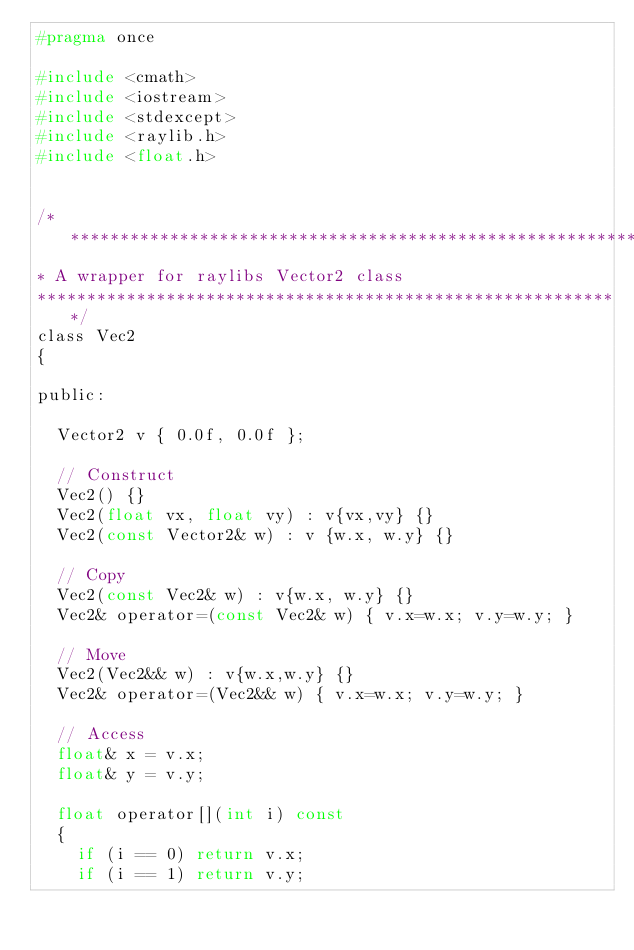<code> <loc_0><loc_0><loc_500><loc_500><_C_>#pragma once

#include <cmath>
#include <iostream>
#include <stdexcept>
#include <raylib.h>
#include <float.h>


/***********************************************************
* A wrapper for raylibs Vector2 class
***********************************************************/
class Vec2
{

public:

  Vector2 v { 0.0f, 0.0f };

  // Construct
  Vec2() {}
  Vec2(float vx, float vy) : v{vx,vy} {}
  Vec2(const Vector2& w) : v {w.x, w.y} {}

  // Copy 
  Vec2(const Vec2& w) : v{w.x, w.y} {}
  Vec2& operator=(const Vec2& w) { v.x=w.x; v.y=w.y; }

  // Move
  Vec2(Vec2&& w) : v{w.x,w.y} {}
  Vec2& operator=(Vec2&& w) { v.x=w.x; v.y=w.y; }

  // Access
  float& x = v.x;
  float& y = v.y;

  float operator[](int i) const 
  {
    if (i == 0) return v.x;
    if (i == 1) return v.y;</code> 